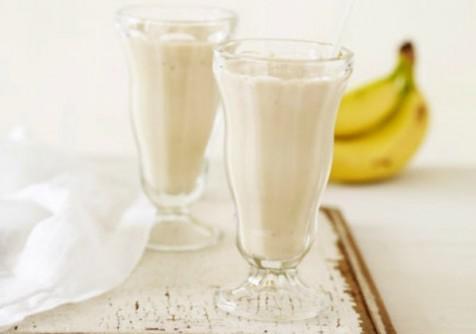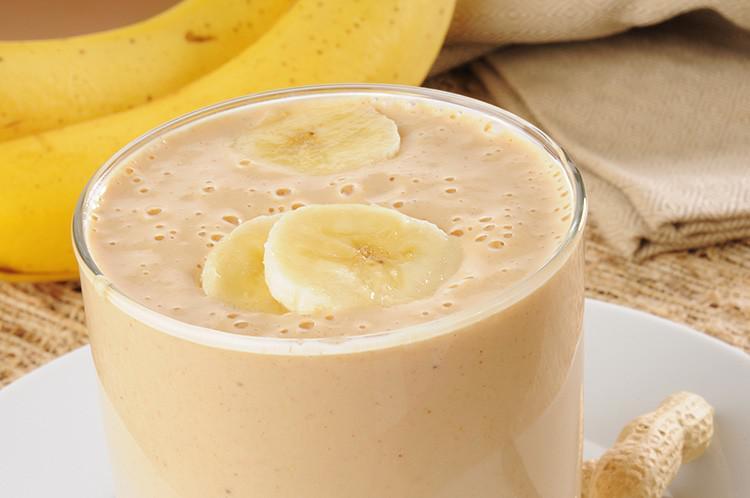The first image is the image on the left, the second image is the image on the right. Evaluate the accuracy of this statement regarding the images: "The straws have stripes on them.". Is it true? Answer yes or no. No. The first image is the image on the left, the second image is the image on the right. Given the left and right images, does the statement "The image on the left shows two smoothie glasses next to at least one banana." hold true? Answer yes or no. Yes. 